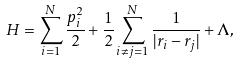<formula> <loc_0><loc_0><loc_500><loc_500>H = \sum _ { i = 1 } ^ { N } \frac { { p } _ { i } ^ { 2 } } { 2 } + \frac { 1 } { 2 } \sum _ { i \ne j = 1 } ^ { N } \frac { 1 } { | { r } _ { i } - { r } _ { j } | } + \Lambda ,</formula> 